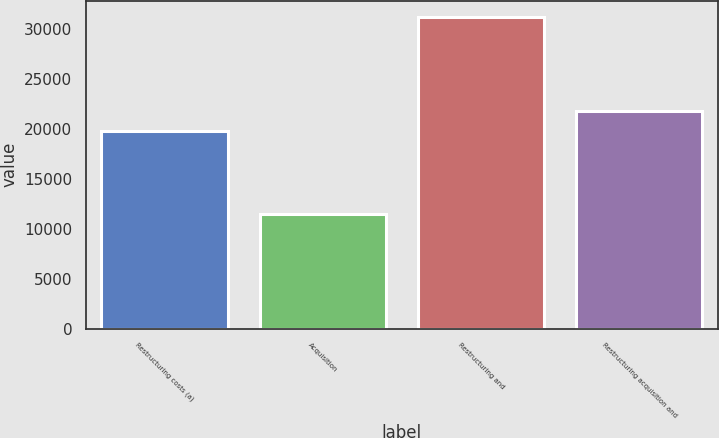Convert chart. <chart><loc_0><loc_0><loc_500><loc_500><bar_chart><fcel>Restructuring costs (a)<fcel>Acquisition<fcel>Restructuring and<fcel>Restructuring acquisition and<nl><fcel>19795<fcel>11426<fcel>31221<fcel>21774.5<nl></chart> 